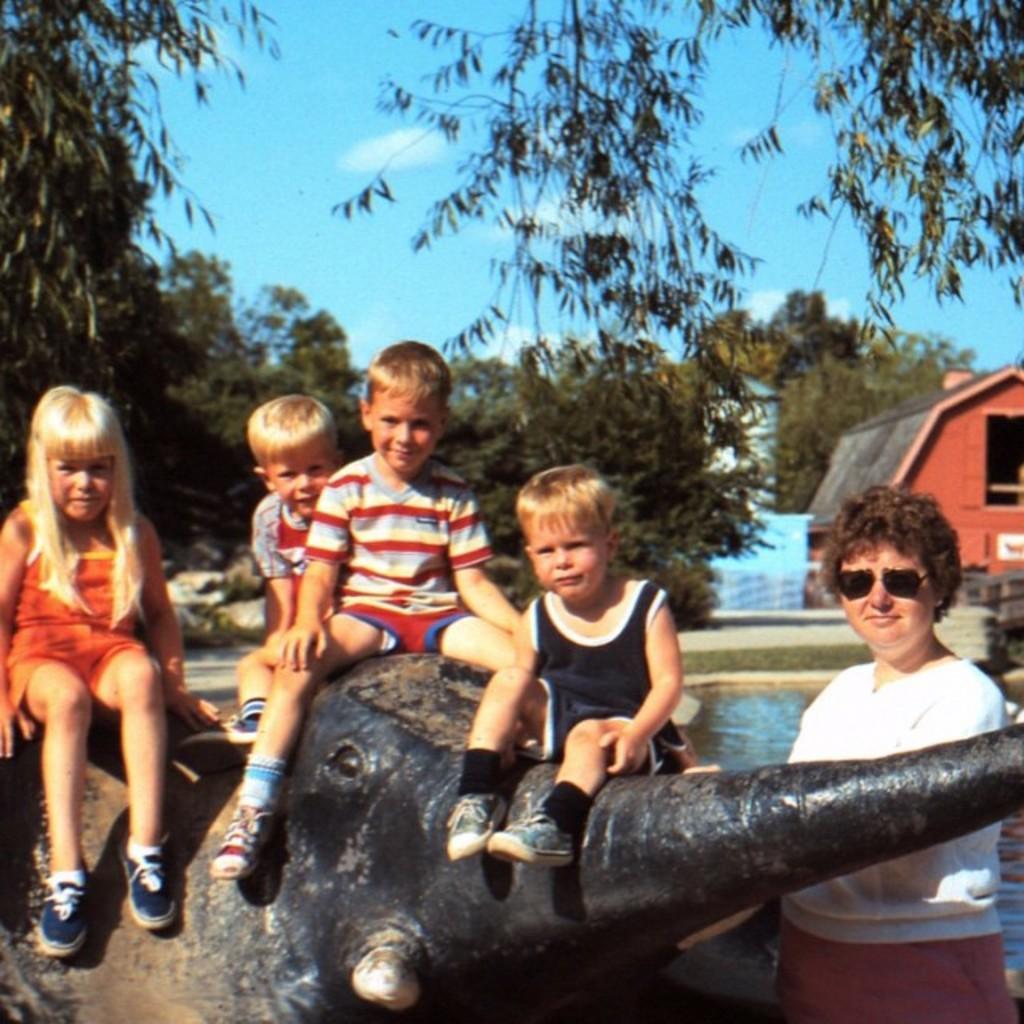In one or two sentences, can you explain what this image depicts? In this image I can see the ground, a statue of an elephant and on it I can see few children sitting. I can see a person standing, the water, few trees, few sheds and in the background I can see the sky. 